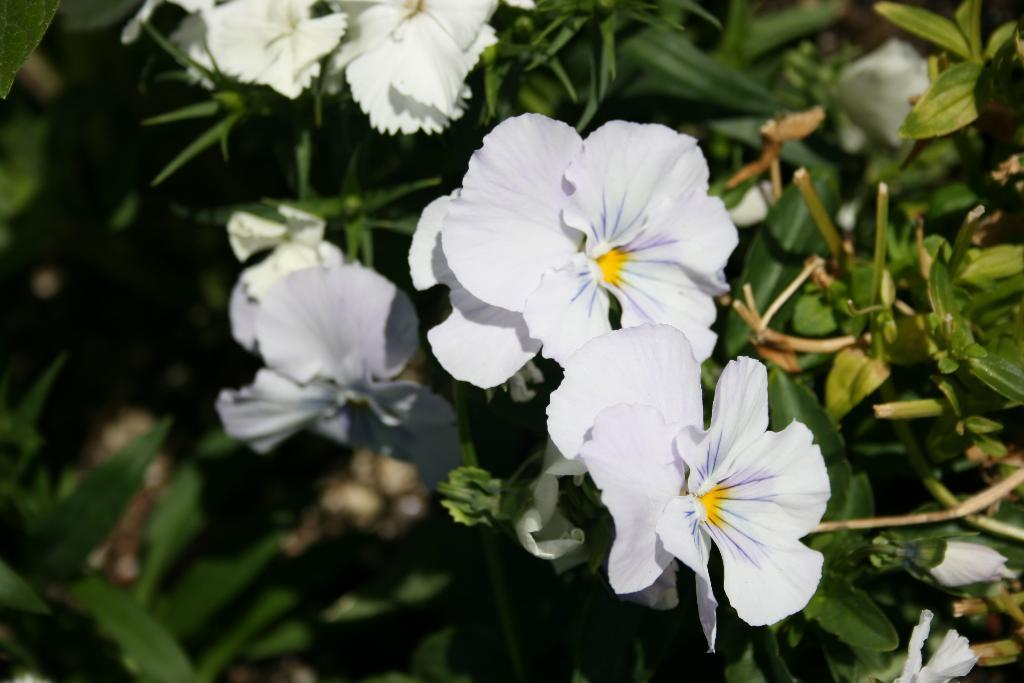What colors are the flowers in the image? The flowers in the image are white and yellow. What color are the leaves in the image? The leaves in the image are green. Can you describe the background of the image? The background of the image is blurred. What color is the sky in the image? There is no sky visible in the image; it only shows flowers and leaves. 